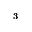Convert formula to latex. <formula><loc_0><loc_0><loc_500><loc_500>^ { 3 }</formula> 